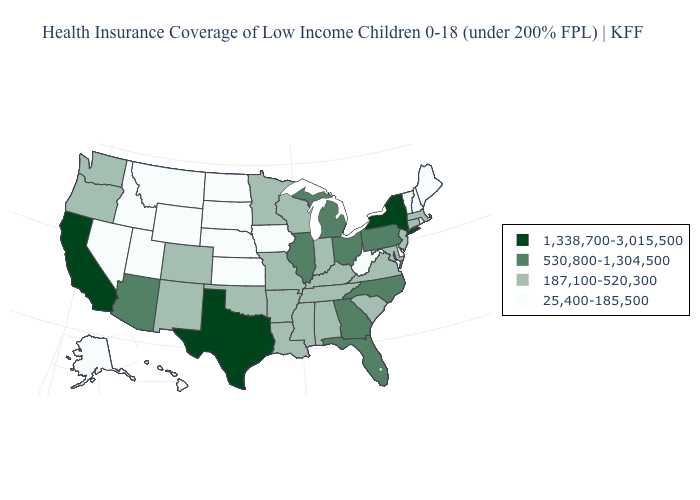Does the first symbol in the legend represent the smallest category?
Be succinct. No. How many symbols are there in the legend?
Give a very brief answer. 4. Which states have the lowest value in the Northeast?
Short answer required. Maine, New Hampshire, Rhode Island, Vermont. What is the highest value in the Northeast ?
Keep it brief. 1,338,700-3,015,500. Does Pennsylvania have the lowest value in the USA?
Quick response, please. No. Does New York have the highest value in the Northeast?
Give a very brief answer. Yes. What is the value of Pennsylvania?
Give a very brief answer. 530,800-1,304,500. Which states hav the highest value in the West?
Quick response, please. California. What is the value of Pennsylvania?
Be succinct. 530,800-1,304,500. Name the states that have a value in the range 187,100-520,300?
Answer briefly. Alabama, Arkansas, Colorado, Connecticut, Indiana, Kentucky, Louisiana, Maryland, Massachusetts, Minnesota, Mississippi, Missouri, New Jersey, New Mexico, Oklahoma, Oregon, South Carolina, Tennessee, Virginia, Washington, Wisconsin. What is the highest value in states that border Nebraska?
Keep it brief. 187,100-520,300. Name the states that have a value in the range 187,100-520,300?
Answer briefly. Alabama, Arkansas, Colorado, Connecticut, Indiana, Kentucky, Louisiana, Maryland, Massachusetts, Minnesota, Mississippi, Missouri, New Jersey, New Mexico, Oklahoma, Oregon, South Carolina, Tennessee, Virginia, Washington, Wisconsin. What is the value of Vermont?
Answer briefly. 25,400-185,500. What is the value of New Jersey?
Be succinct. 187,100-520,300. Name the states that have a value in the range 1,338,700-3,015,500?
Concise answer only. California, New York, Texas. 